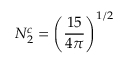Convert formula to latex. <formula><loc_0><loc_0><loc_500><loc_500>N _ { 2 } ^ { c } = \left ( { \frac { 1 5 } { 4 \pi } } \right ) ^ { 1 / 2 }</formula> 